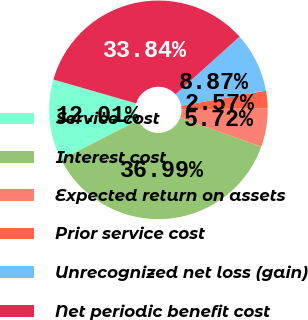<chart> <loc_0><loc_0><loc_500><loc_500><pie_chart><fcel>Service cost<fcel>Interest cost<fcel>Expected return on assets<fcel>Prior service cost<fcel>Unrecognized net loss (gain)<fcel>Net periodic benefit cost<nl><fcel>12.01%<fcel>36.99%<fcel>5.72%<fcel>2.57%<fcel>8.87%<fcel>33.84%<nl></chart> 